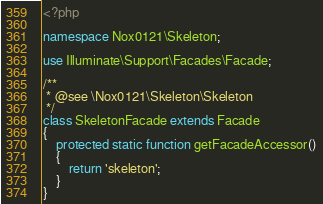<code> <loc_0><loc_0><loc_500><loc_500><_PHP_><?php

namespace Nox0121\Skeleton;

use Illuminate\Support\Facades\Facade;

/**
 * @see \Nox0121\Skeleton\Skeleton
 */
class SkeletonFacade extends Facade
{
    protected static function getFacadeAccessor()
    {
        return 'skeleton';
    }
}
</code> 